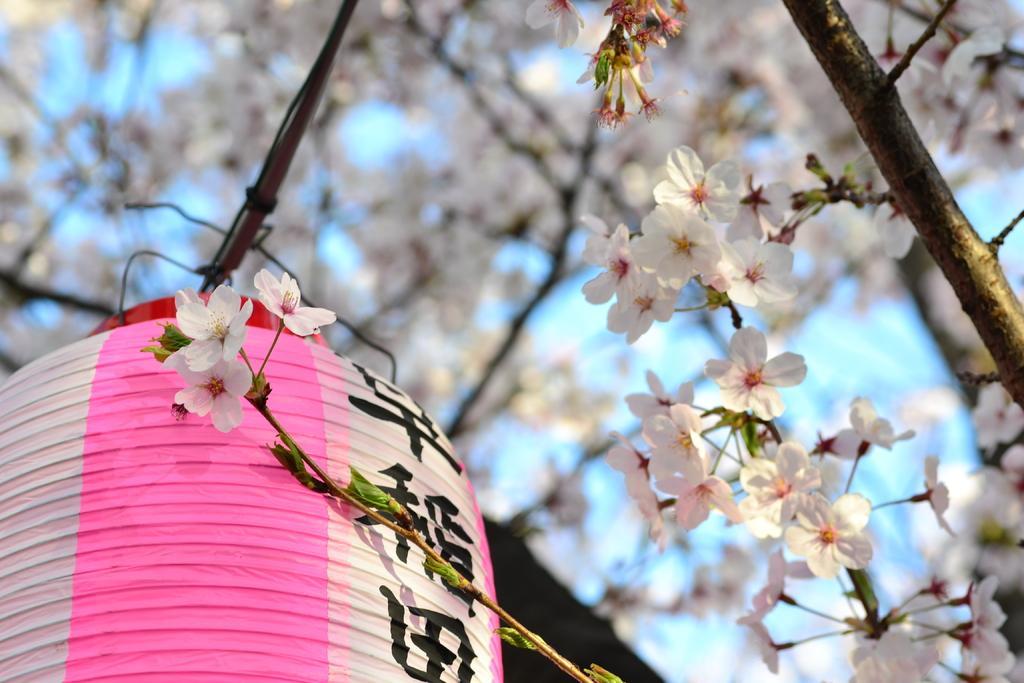In one or two sentences, can you explain what this image depicts? In this image there are flowers and a lantern, in the background it is blurred. 